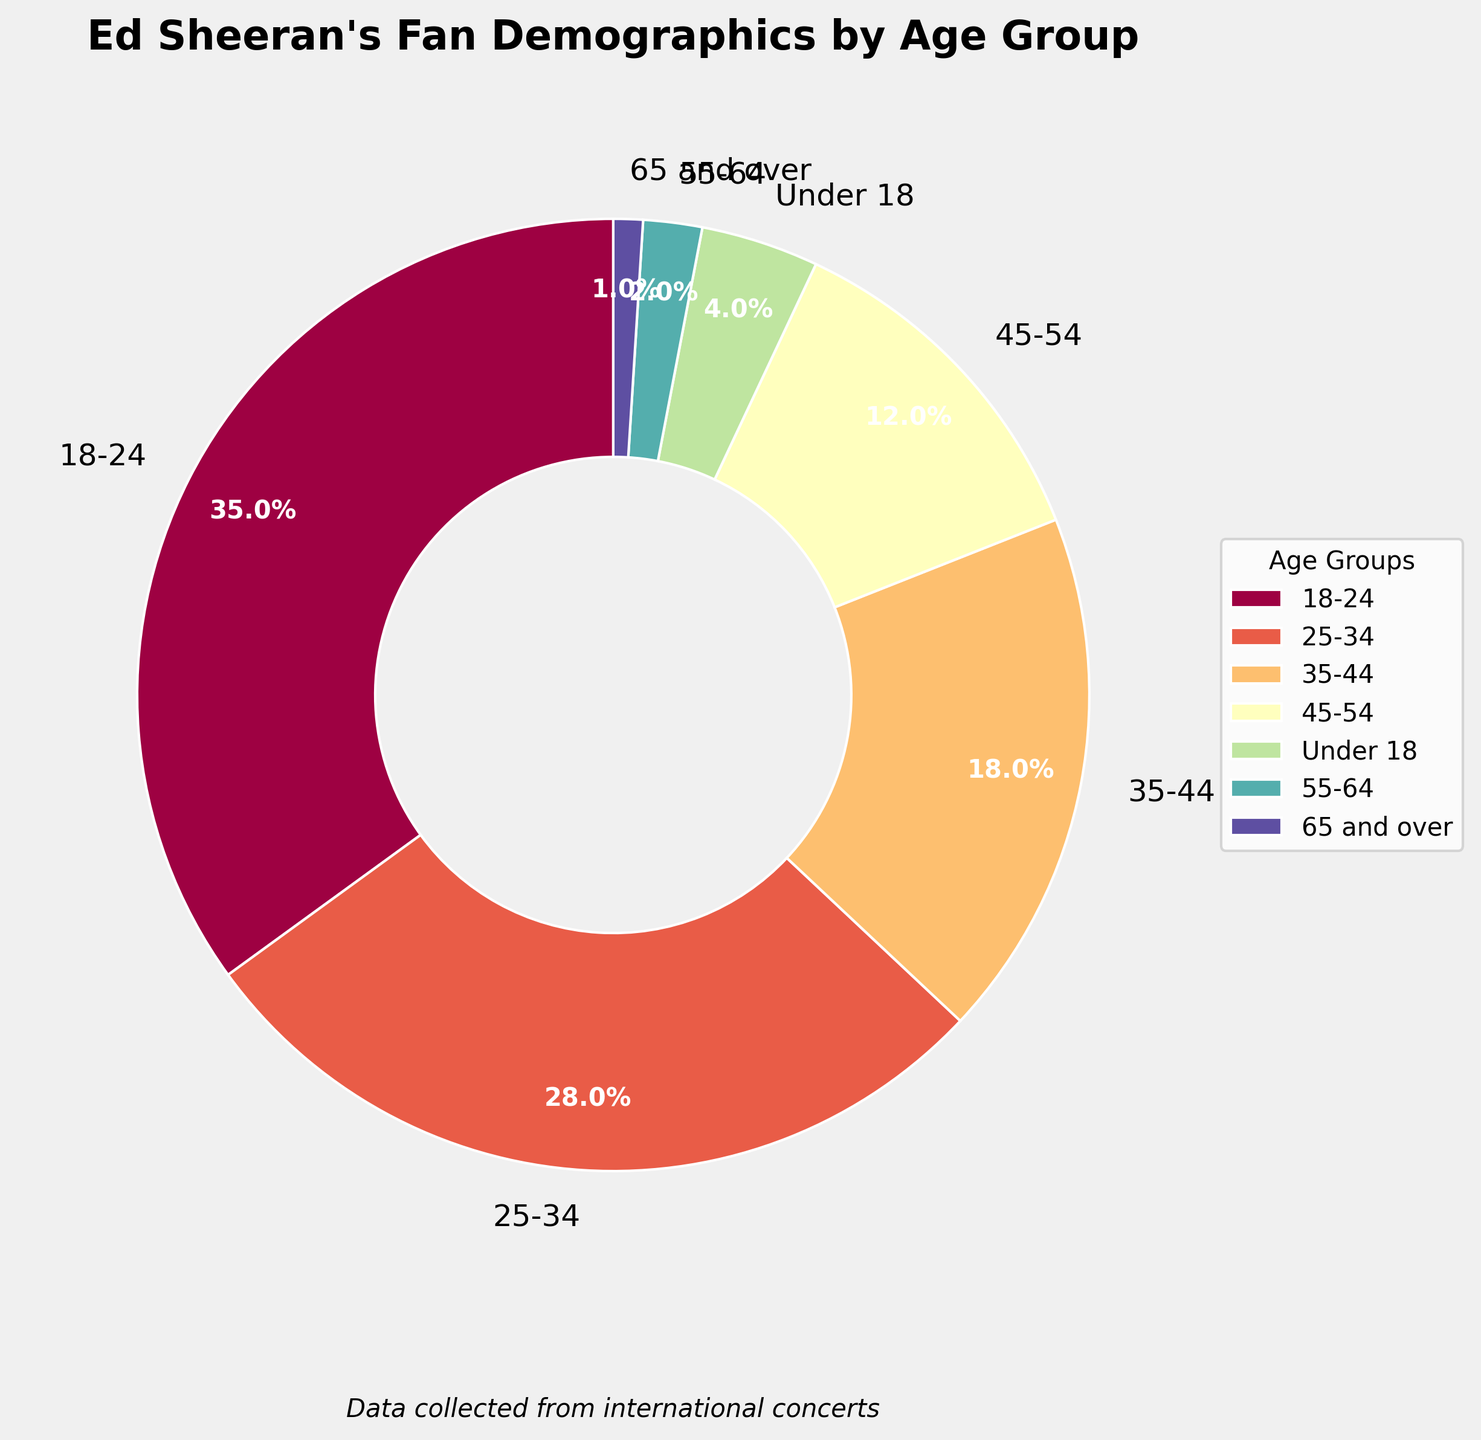Which age group has the largest percentage of fans at Ed Sheeran's concerts? To find the largest percentage, look at the percentage values for each age group. The group with the highest value is the one with the largest percentage. In this case, the 18-24 age group has 35%.
Answer: 18-24 What is the combined percentage of fans aged 45 and above? Add the percentages for fans aged 45-54, 55-64, and 65 and over. This is 12% + 2% + 1% = 15%.
Answer: 15% How does the percentage of fans under 18 compare to those aged 35-44? Compare the percentage values for fans under 18 (4%) and those aged 35-44 (18%). The percentage of fans aged 35-44 is higher.
Answer: Fans aged 35-44 have a higher percentage What is the difference in percentage between the 18-24 age group and the 25-34 age group? Subtract the percentage of the 25-34 age group (28%) from the 18-24 age group (35%). The difference is 35% - 28% = 7%.
Answer: 7% Which age group has the smallest percentage of fans? Look for the age group with the lowest percentage value. The 65 and over age group has the smallest percentage at 1%.
Answer: 65 and over What is the total percentage of fans aged 18 to 34? Add the percentages for the 18-24 age group and the 25-34 age group. This is 35% + 28% = 63%.
Answer: 63% Which age group is represented by the largest wedge in the pie chart? The largest wedge in a pie chart corresponds to the age group with the highest percentage. The 18-24 age group, which has 35%, is represented by the largest wedge.
Answer: 18-24 Is the percentage of fans in the 35-44 age group more than double that of the 45-54 age group? Doubling the 45-54 age group's percentage gives 12% × 2 = 24%. The percentage for the 35-44 group is 18%, which is less than 24%.
Answer: No Which age group has a percentage closest to the average of all age groups? Calculate the average percentage by summing all the percentages (35% + 28% + 18% + 12% + 4% + 2% + 1% = 100%) and dividing by the number of groups (7). The average is 100% / 7 ≈ 14.3%. The 45-54 age group with 12% is closest to 14.3%.
Answer: 45-54 